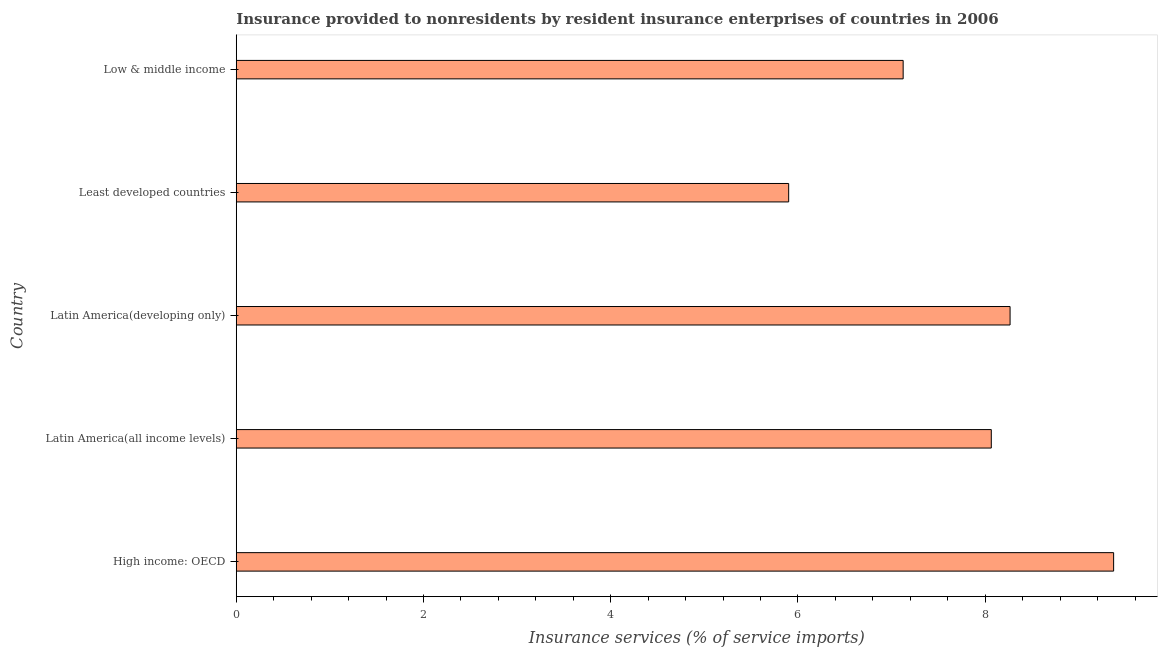Does the graph contain grids?
Ensure brevity in your answer.  No. What is the title of the graph?
Provide a succinct answer. Insurance provided to nonresidents by resident insurance enterprises of countries in 2006. What is the label or title of the X-axis?
Make the answer very short. Insurance services (% of service imports). What is the label or title of the Y-axis?
Keep it short and to the point. Country. What is the insurance and financial services in High income: OECD?
Your answer should be very brief. 9.37. Across all countries, what is the maximum insurance and financial services?
Provide a short and direct response. 9.37. Across all countries, what is the minimum insurance and financial services?
Your answer should be compact. 5.9. In which country was the insurance and financial services maximum?
Give a very brief answer. High income: OECD. In which country was the insurance and financial services minimum?
Your answer should be very brief. Least developed countries. What is the sum of the insurance and financial services?
Offer a terse response. 38.73. What is the difference between the insurance and financial services in Latin America(all income levels) and Latin America(developing only)?
Your response must be concise. -0.2. What is the average insurance and financial services per country?
Your response must be concise. 7.75. What is the median insurance and financial services?
Your answer should be compact. 8.06. What is the ratio of the insurance and financial services in High income: OECD to that in Least developed countries?
Provide a short and direct response. 1.59. Is the insurance and financial services in High income: OECD less than that in Latin America(developing only)?
Offer a terse response. No. Is the difference between the insurance and financial services in Latin America(developing only) and Low & middle income greater than the difference between any two countries?
Provide a succinct answer. No. What is the difference between the highest and the second highest insurance and financial services?
Your response must be concise. 1.11. What is the difference between the highest and the lowest insurance and financial services?
Offer a terse response. 3.47. Are all the bars in the graph horizontal?
Offer a terse response. Yes. How many countries are there in the graph?
Make the answer very short. 5. What is the Insurance services (% of service imports) in High income: OECD?
Your response must be concise. 9.37. What is the Insurance services (% of service imports) of Latin America(all income levels)?
Your response must be concise. 8.06. What is the Insurance services (% of service imports) in Latin America(developing only)?
Provide a succinct answer. 8.27. What is the Insurance services (% of service imports) of Least developed countries?
Offer a very short reply. 5.9. What is the Insurance services (% of service imports) of Low & middle income?
Provide a succinct answer. 7.12. What is the difference between the Insurance services (% of service imports) in High income: OECD and Latin America(all income levels)?
Offer a terse response. 1.31. What is the difference between the Insurance services (% of service imports) in High income: OECD and Latin America(developing only)?
Ensure brevity in your answer.  1.11. What is the difference between the Insurance services (% of service imports) in High income: OECD and Least developed countries?
Keep it short and to the point. 3.47. What is the difference between the Insurance services (% of service imports) in High income: OECD and Low & middle income?
Your answer should be compact. 2.25. What is the difference between the Insurance services (% of service imports) in Latin America(all income levels) and Latin America(developing only)?
Your response must be concise. -0.2. What is the difference between the Insurance services (% of service imports) in Latin America(all income levels) and Least developed countries?
Your answer should be compact. 2.16. What is the difference between the Insurance services (% of service imports) in Latin America(all income levels) and Low & middle income?
Offer a terse response. 0.94. What is the difference between the Insurance services (% of service imports) in Latin America(developing only) and Least developed countries?
Provide a short and direct response. 2.37. What is the difference between the Insurance services (% of service imports) in Latin America(developing only) and Low & middle income?
Provide a short and direct response. 1.14. What is the difference between the Insurance services (% of service imports) in Least developed countries and Low & middle income?
Ensure brevity in your answer.  -1.22. What is the ratio of the Insurance services (% of service imports) in High income: OECD to that in Latin America(all income levels)?
Make the answer very short. 1.16. What is the ratio of the Insurance services (% of service imports) in High income: OECD to that in Latin America(developing only)?
Give a very brief answer. 1.13. What is the ratio of the Insurance services (% of service imports) in High income: OECD to that in Least developed countries?
Your answer should be compact. 1.59. What is the ratio of the Insurance services (% of service imports) in High income: OECD to that in Low & middle income?
Give a very brief answer. 1.32. What is the ratio of the Insurance services (% of service imports) in Latin America(all income levels) to that in Latin America(developing only)?
Give a very brief answer. 0.98. What is the ratio of the Insurance services (% of service imports) in Latin America(all income levels) to that in Least developed countries?
Your response must be concise. 1.37. What is the ratio of the Insurance services (% of service imports) in Latin America(all income levels) to that in Low & middle income?
Make the answer very short. 1.13. What is the ratio of the Insurance services (% of service imports) in Latin America(developing only) to that in Least developed countries?
Provide a short and direct response. 1.4. What is the ratio of the Insurance services (% of service imports) in Latin America(developing only) to that in Low & middle income?
Your response must be concise. 1.16. What is the ratio of the Insurance services (% of service imports) in Least developed countries to that in Low & middle income?
Ensure brevity in your answer.  0.83. 